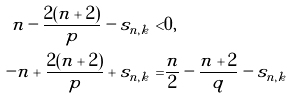<formula> <loc_0><loc_0><loc_500><loc_500>n - \frac { 2 ( n + 2 ) } { p } - s _ { n , k } < & 0 , \\ - n + \frac { 2 ( n + 2 ) } { p } + s _ { n , k } = & \frac { n } { 2 } - \frac { n + 2 } q - s _ { n , k }</formula> 